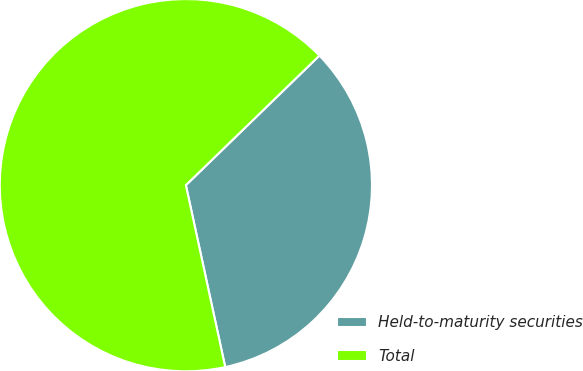Convert chart. <chart><loc_0><loc_0><loc_500><loc_500><pie_chart><fcel>Held-to-maturity securities<fcel>Total<nl><fcel>33.87%<fcel>66.13%<nl></chart> 